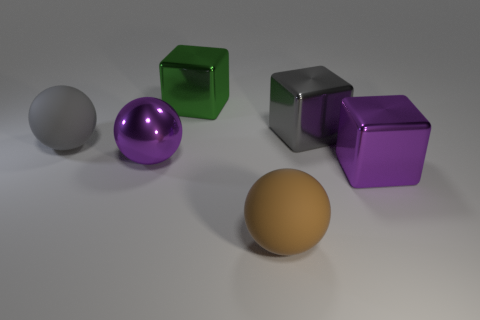There is a purple object that is left of the big brown ball; are there any brown spheres behind it?
Keep it short and to the point. No. Is the gray thing that is left of the big brown matte object made of the same material as the big green cube?
Offer a very short reply. No. What number of other objects are there of the same color as the metal ball?
Give a very brief answer. 1. What size is the block that is in front of the big rubber ball behind the large brown rubber thing?
Provide a succinct answer. Large. Do the gray thing to the left of the big green shiny thing and the ball to the right of the purple shiny sphere have the same material?
Your answer should be compact. Yes. There is a rubber sphere to the right of the green metal block; does it have the same color as the shiny ball?
Ensure brevity in your answer.  No. How many large gray metallic cubes are behind the big purple cube?
Your response must be concise. 1. Is the green block made of the same material as the large purple cube in front of the purple metal sphere?
Your answer should be very brief. Yes. What is the size of the purple cube that is the same material as the large gray cube?
Your answer should be compact. Large. Is the number of large metallic spheres that are left of the brown matte thing greater than the number of big metal blocks that are behind the purple metallic ball?
Make the answer very short. No. 